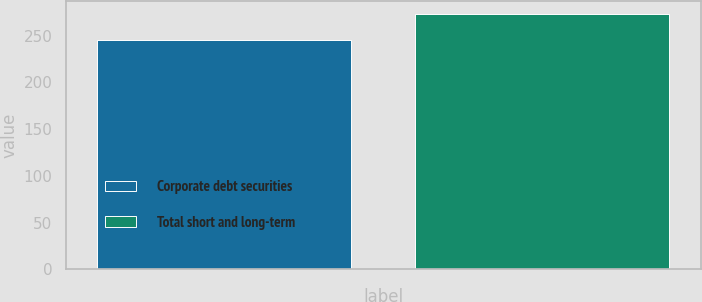Convert chart. <chart><loc_0><loc_0><loc_500><loc_500><bar_chart><fcel>Corporate debt securities<fcel>Total short and long-term<nl><fcel>245.7<fcel>273.5<nl></chart> 